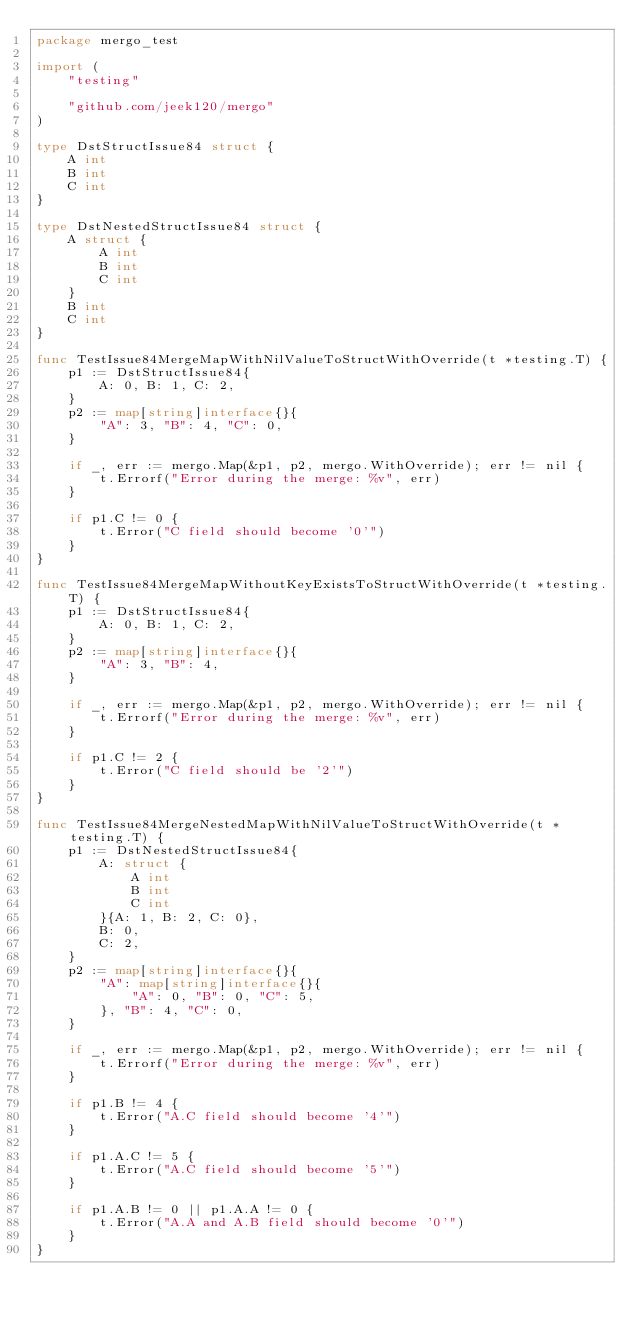<code> <loc_0><loc_0><loc_500><loc_500><_Go_>package mergo_test

import (
	"testing"

	"github.com/jeek120/mergo"
)

type DstStructIssue84 struct {
	A int
	B int
	C int
}

type DstNestedStructIssue84 struct {
	A struct {
		A int
		B int
		C int
	}
	B int
	C int
}

func TestIssue84MergeMapWithNilValueToStructWithOverride(t *testing.T) {
	p1 := DstStructIssue84{
		A: 0, B: 1, C: 2,
	}
	p2 := map[string]interface{}{
		"A": 3, "B": 4, "C": 0,
	}

	if _, err := mergo.Map(&p1, p2, mergo.WithOverride); err != nil {
		t.Errorf("Error during the merge: %v", err)
	}

	if p1.C != 0 {
		t.Error("C field should become '0'")
	}
}

func TestIssue84MergeMapWithoutKeyExistsToStructWithOverride(t *testing.T) {
	p1 := DstStructIssue84{
		A: 0, B: 1, C: 2,
	}
	p2 := map[string]interface{}{
		"A": 3, "B": 4,
	}

	if _, err := mergo.Map(&p1, p2, mergo.WithOverride); err != nil {
		t.Errorf("Error during the merge: %v", err)
	}

	if p1.C != 2 {
		t.Error("C field should be '2'")
	}
}

func TestIssue84MergeNestedMapWithNilValueToStructWithOverride(t *testing.T) {
	p1 := DstNestedStructIssue84{
		A: struct {
			A int
			B int
			C int
		}{A: 1, B: 2, C: 0},
		B: 0,
		C: 2,
	}
	p2 := map[string]interface{}{
		"A": map[string]interface{}{
			"A": 0, "B": 0, "C": 5,
		}, "B": 4, "C": 0,
	}

	if _, err := mergo.Map(&p1, p2, mergo.WithOverride); err != nil {
		t.Errorf("Error during the merge: %v", err)
	}

	if p1.B != 4 {
		t.Error("A.C field should become '4'")
	}

	if p1.A.C != 5 {
		t.Error("A.C field should become '5'")
	}

	if p1.A.B != 0 || p1.A.A != 0 {
		t.Error("A.A and A.B field should become '0'")
	}
}
</code> 